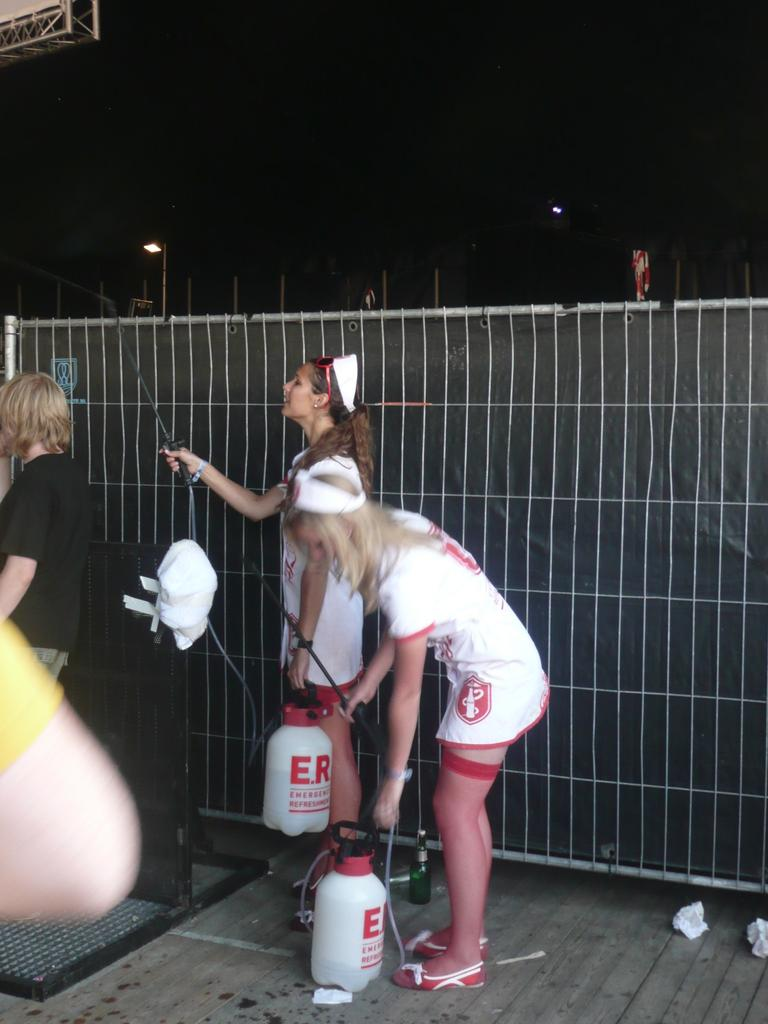<image>
Summarize the visual content of the image. Women in nurse costumes holding containers that say ER. 